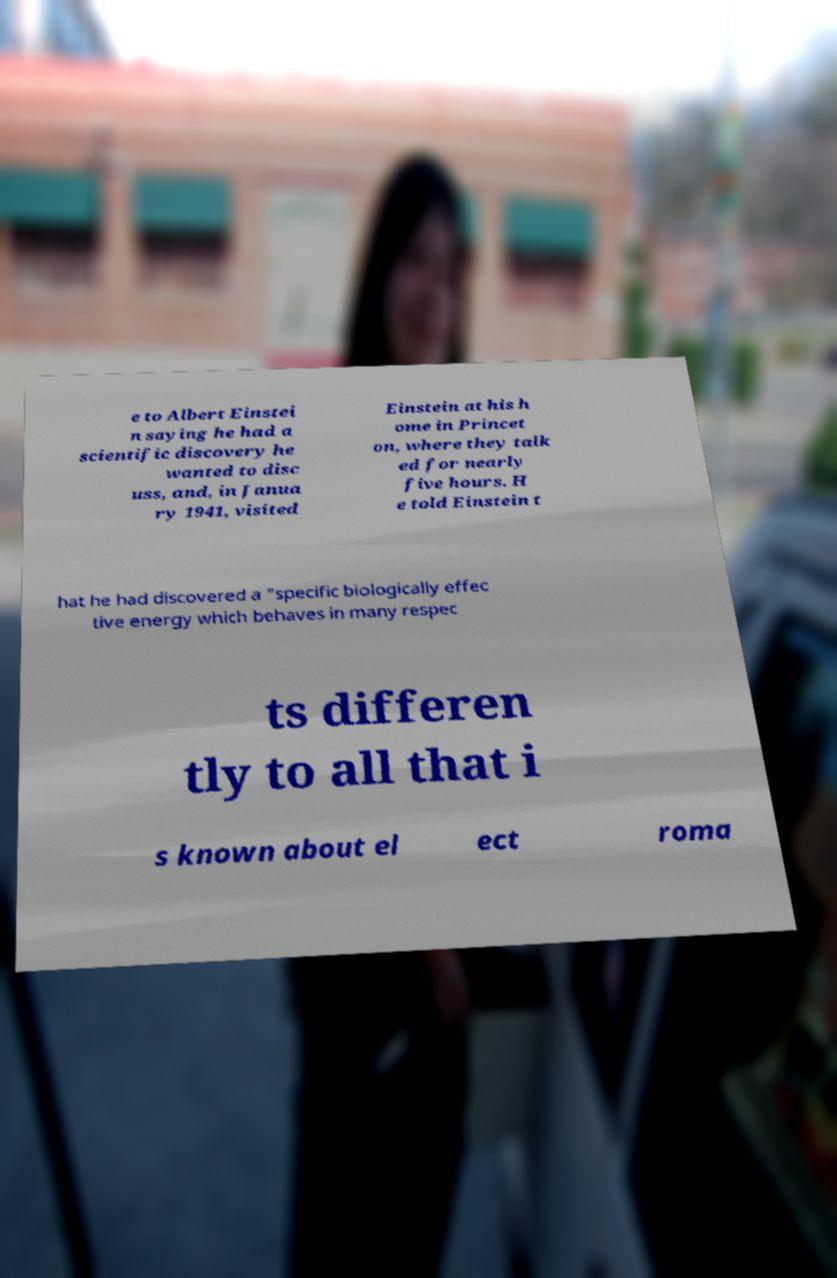What messages or text are displayed in this image? I need them in a readable, typed format. e to Albert Einstei n saying he had a scientific discovery he wanted to disc uss, and, in Janua ry 1941, visited Einstein at his h ome in Princet on, where they talk ed for nearly five hours. H e told Einstein t hat he had discovered a "specific biologically effec tive energy which behaves in many respec ts differen tly to all that i s known about el ect roma 